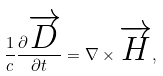Convert formula to latex. <formula><loc_0><loc_0><loc_500><loc_500>\frac { 1 } { c } \frac { \partial \overrightarrow { D } } { \partial t } = \nabla \times \overrightarrow { H } ,</formula> 